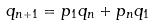<formula> <loc_0><loc_0><loc_500><loc_500>q _ { n + 1 } = p _ { 1 } q _ { n } + p _ { n } q _ { 1 }</formula> 